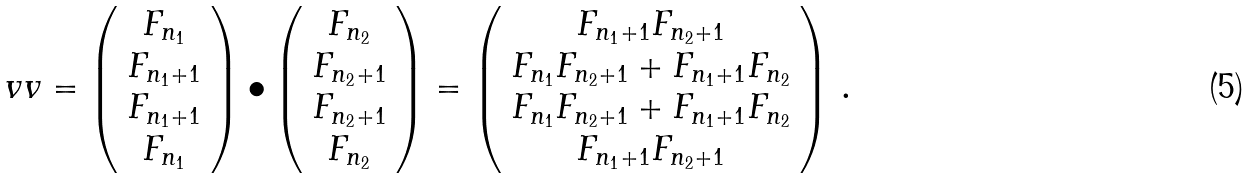Convert formula to latex. <formula><loc_0><loc_0><loc_500><loc_500>\ v v = \left ( \begin{array} { c c c c } F _ { n _ { 1 } } \\ F _ { n _ { 1 } + 1 } \\ F _ { n _ { 1 } + 1 } \\ F _ { n _ { 1 } } \end{array} \right ) \bullet \left ( \begin{array} { c c c c } F _ { n _ { 2 } } \\ F _ { n _ { 2 } + 1 } \\ F _ { n _ { 2 } + 1 } \\ F _ { n _ { 2 } } \end{array} \right ) = \left ( \begin{array} { c c c c } F _ { n _ { 1 } + 1 } F _ { n _ { 2 } + 1 } \\ F _ { n _ { 1 } } F _ { n _ { 2 } + 1 } + F _ { n _ { 1 } + 1 } F _ { n _ { 2 } } \\ F _ { n _ { 1 } } F _ { n _ { 2 } + 1 } + F _ { n _ { 1 } + 1 } F _ { n _ { 2 } } \\ F _ { n _ { 1 } + 1 } F _ { n _ { 2 } + 1 } \end{array} \right ) \, .</formula> 